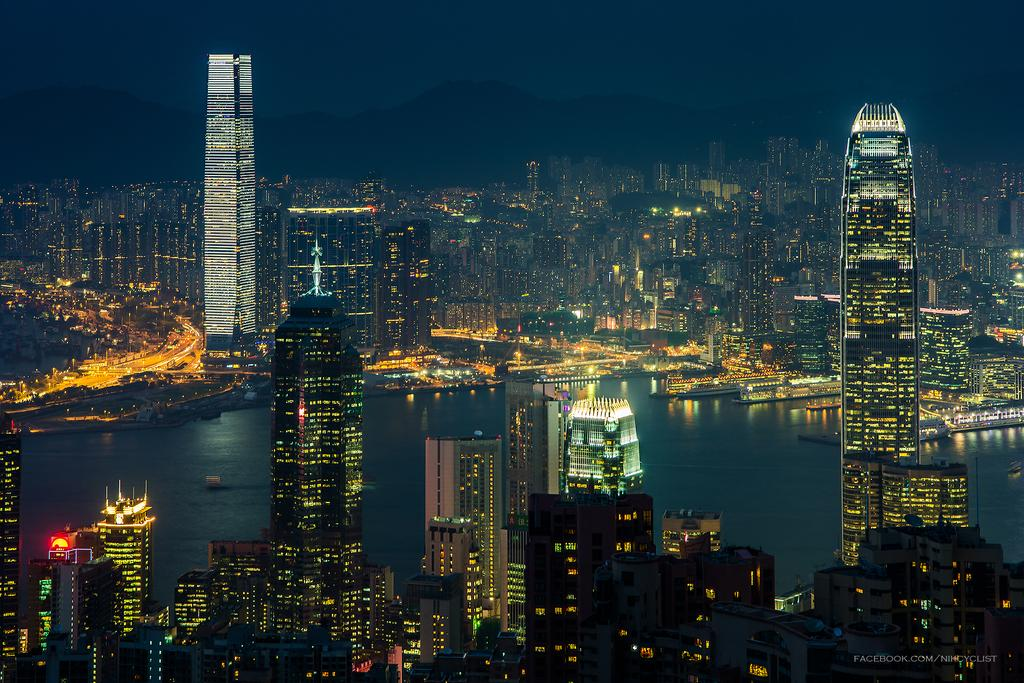What type of location is shown in the image? The image depicts a city. What are some notable features of the city in the image? There are skyscrapers in the image. What natural element can be seen in the image? There is water visible in the image. What type of geographical feature is present in the image? There are hills in the image. What can be seen in the background of the image? The sky is visible in the background of the image. Where is the library located in the image? There is no library mentioned or visible in the image. What type of organization is depicted in the image? The image does not depict any specific organization; it shows a cityscape with skyscrapers, water, hills, and the sky. Can you tell me how many birds are flying in the image? There are no birds visible in the image. 